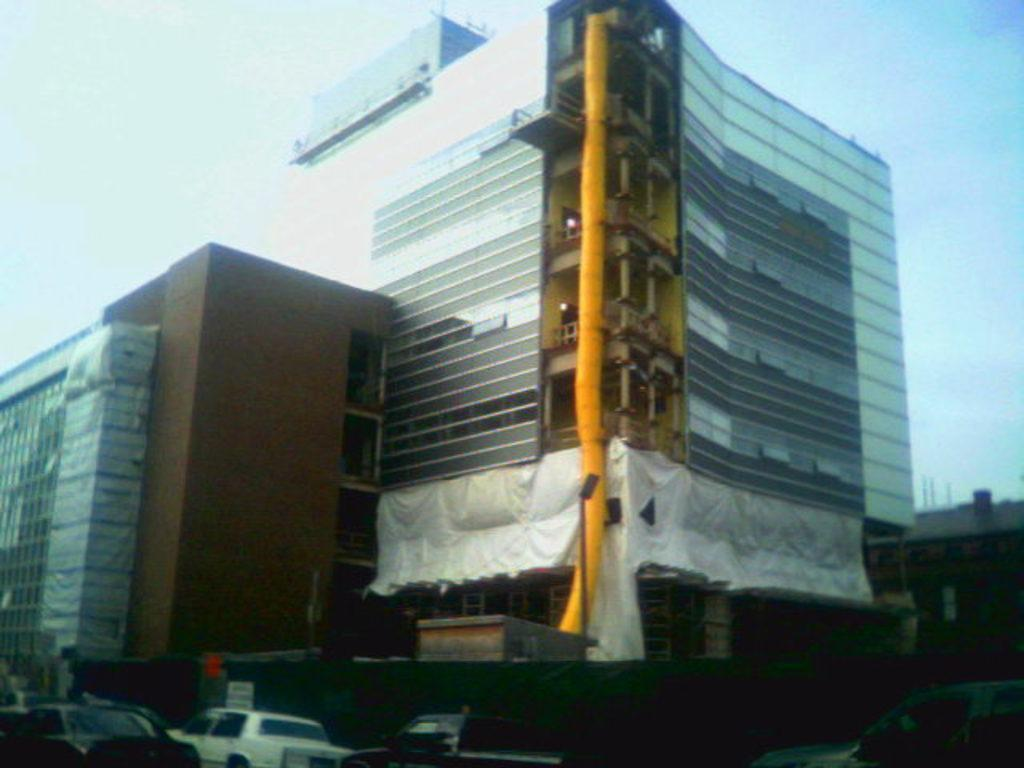What types of objects can be seen in the image? There are vehicles and buildings in the image. What can be seen in the background of the image? The sky is visible in the background of the image. What type of magic is being performed in the image? There is no magic being performed in the image; it features vehicles, buildings, and the sky. 